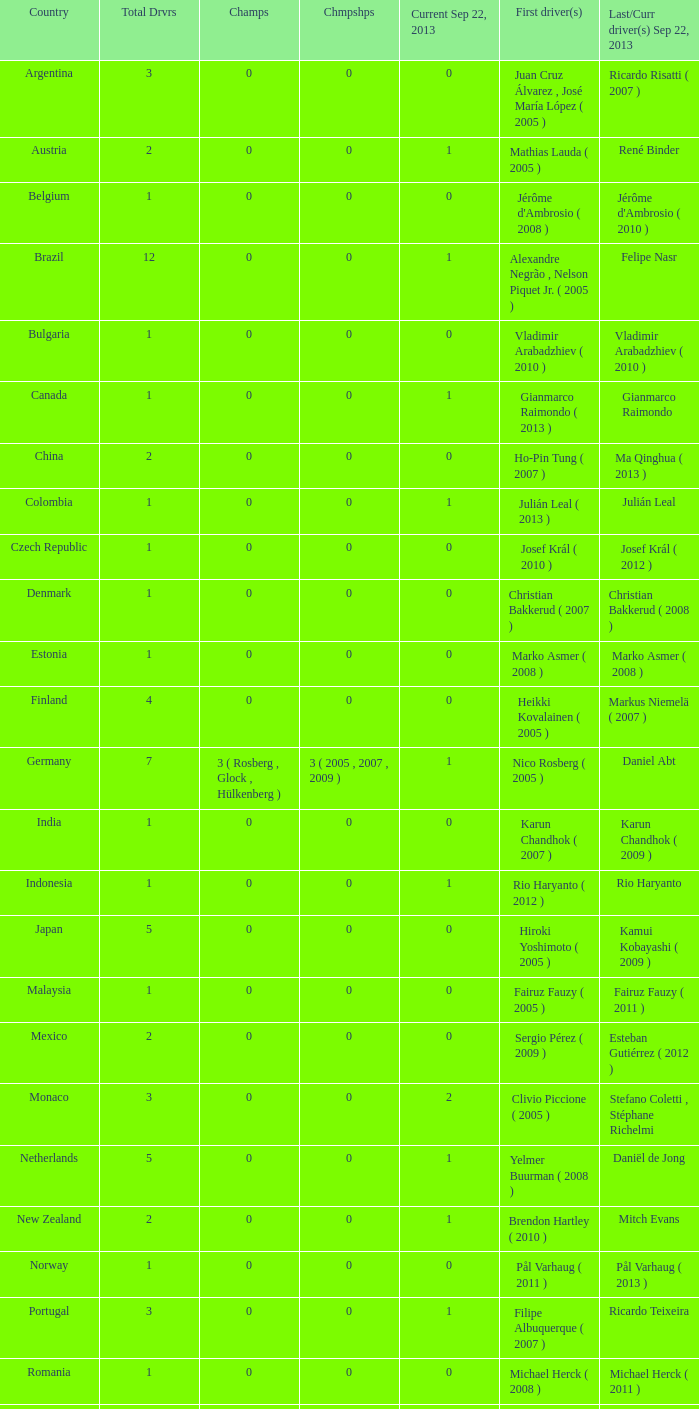How many entries are there for first driver for Canada? 1.0. 